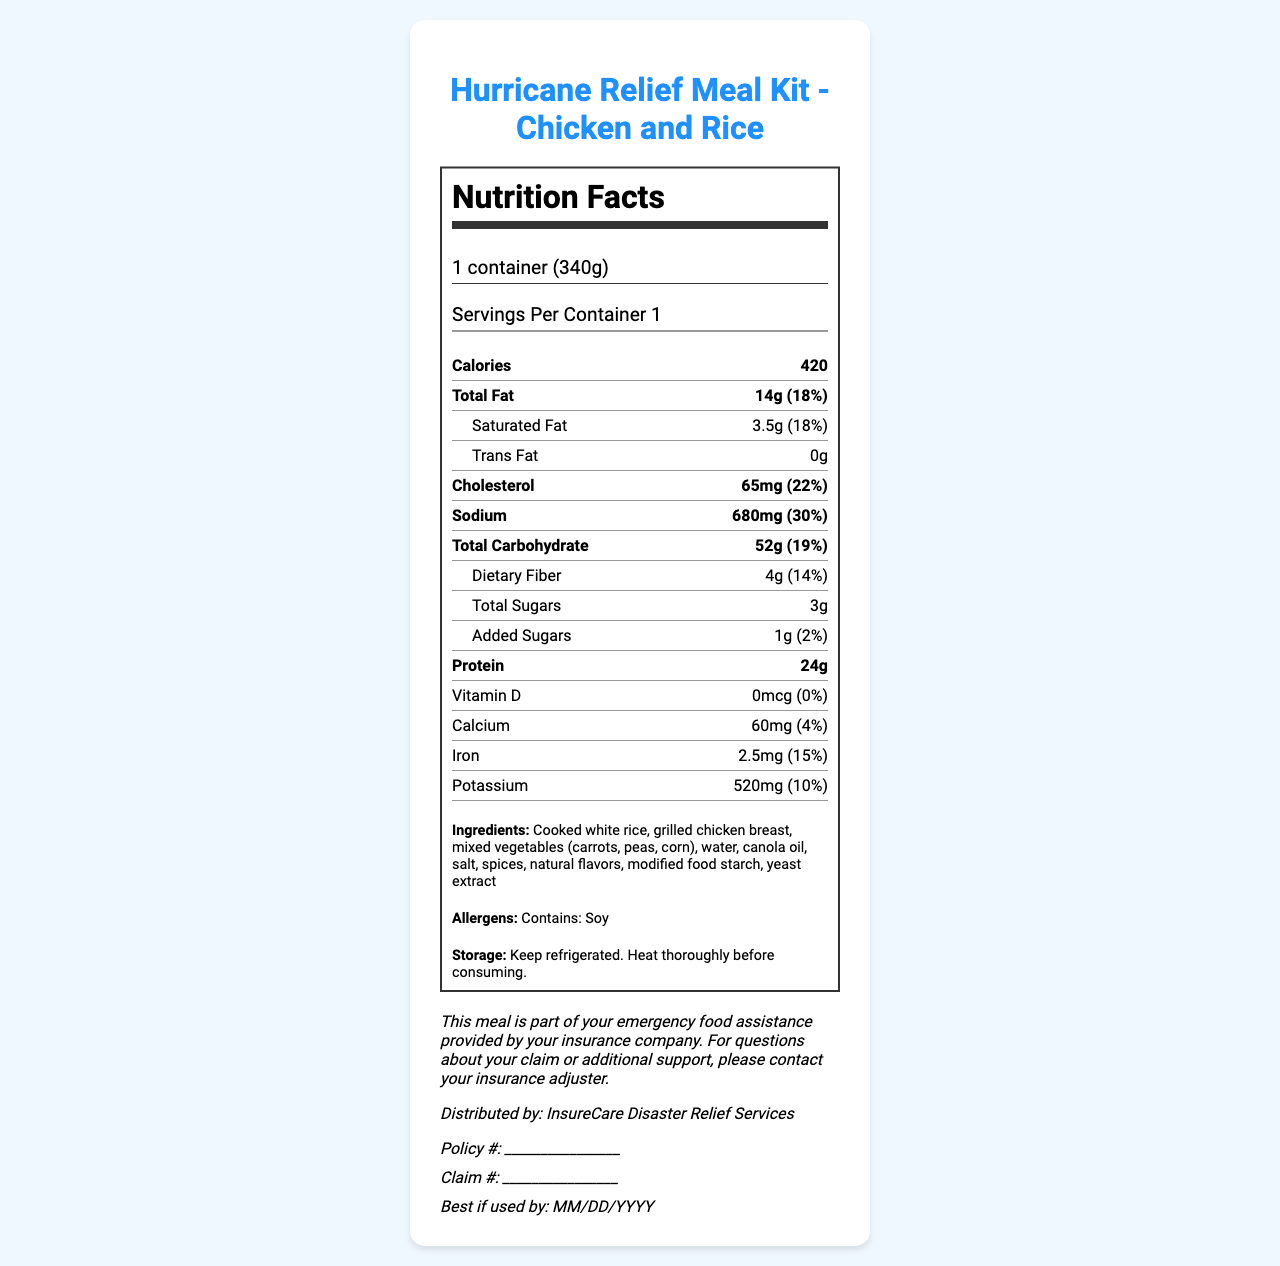what is the serving size? The serving size is explicitly stated as "1 container (340g)" in the document.
Answer: 1 container (340g) how many calories are in one serving? The document lists "Calories" as 420.
Answer: 420 what percentage of the daily value is the total fat? The document states that the total fat has a daily value of 18%.
Answer: 18% how much protein does the meal kit contain? The protein content is listed as "24g" in the document.
Answer: 24g what are the allergens listed for this meal kit? Allergens are specifically mentioned as "Contains: Soy".
Answer: Contains: Soy what is the best way to store this meal? The document provides storage instructions: "Keep refrigerated. Heat thoroughly before consuming."
Answer: Keep refrigerated. Heat thoroughly before consuming. which nutrient has the highest daily value percentage? A. Protein B. Cholesterol C. Sodium D. Iron Sodium has a daily value of 30%, which is higher than the other listed nutrients.
Answer: C. Sodium how many grams of saturated fat are there in one serving? A. 2g B. 3.5g C. 4g D. 14g The document states there are 3.5g of saturated fat per serving.
Answer: B. 3.5g is there any Vitamin D in the meal kit? The document lists Vitamin D as "0mcg (0%)", indicating no Vitamin D is present.
Answer: No do the ingredients include any type of meat? The ingredients list includes "grilled chicken breast", confirming the presence of meat.
Answer: Yes summarize the main information provided in the document. The document summarizes key aspects of the meal kit, including its nutritional content, ingredient list, allergen warnings, and practical instructions for storage and usage, all intended for policyholders affected by natural disasters.
Answer: The document is a Nutrition Facts Label for a Hurricane Relief Meal Kit containing Chicken and Rice. It includes nutritional information, ingredients, allergens, storage instructions, and additional information about the meal's distribution and usage. The label also allows policyholders to fill in their policy and claim numbers. what is the expiration date of the meal kit? The document includes a placeholder "Best if used by: MM/DD/YYYY" but does not provide a specific expiration date.
Answer: Not enough information 